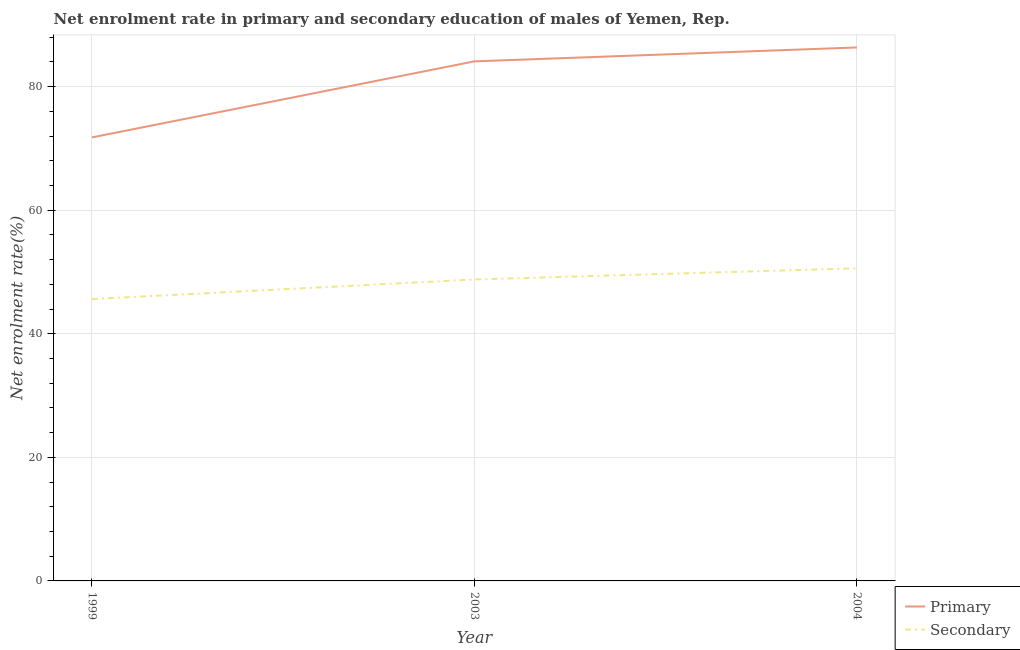How many different coloured lines are there?
Offer a terse response. 2. Does the line corresponding to enrollment rate in secondary education intersect with the line corresponding to enrollment rate in primary education?
Give a very brief answer. No. Is the number of lines equal to the number of legend labels?
Keep it short and to the point. Yes. What is the enrollment rate in secondary education in 2004?
Ensure brevity in your answer.  50.61. Across all years, what is the maximum enrollment rate in secondary education?
Offer a very short reply. 50.61. Across all years, what is the minimum enrollment rate in secondary education?
Provide a short and direct response. 45.62. In which year was the enrollment rate in secondary education minimum?
Keep it short and to the point. 1999. What is the total enrollment rate in primary education in the graph?
Your response must be concise. 242.25. What is the difference between the enrollment rate in primary education in 2003 and that in 2004?
Offer a terse response. -2.25. What is the difference between the enrollment rate in primary education in 2004 and the enrollment rate in secondary education in 1999?
Give a very brief answer. 40.73. What is the average enrollment rate in secondary education per year?
Your answer should be compact. 48.34. In the year 1999, what is the difference between the enrollment rate in secondary education and enrollment rate in primary education?
Your answer should be very brief. -26.17. In how many years, is the enrollment rate in primary education greater than 40 %?
Make the answer very short. 3. What is the ratio of the enrollment rate in secondary education in 1999 to that in 2004?
Your answer should be compact. 0.9. Is the enrollment rate in primary education in 1999 less than that in 2004?
Provide a succinct answer. Yes. Is the difference between the enrollment rate in secondary education in 1999 and 2004 greater than the difference between the enrollment rate in primary education in 1999 and 2004?
Your answer should be very brief. Yes. What is the difference between the highest and the second highest enrollment rate in primary education?
Make the answer very short. 2.25. What is the difference between the highest and the lowest enrollment rate in primary education?
Give a very brief answer. 14.56. In how many years, is the enrollment rate in secondary education greater than the average enrollment rate in secondary education taken over all years?
Ensure brevity in your answer.  2. Does the enrollment rate in secondary education monotonically increase over the years?
Provide a short and direct response. Yes. Is the enrollment rate in secondary education strictly less than the enrollment rate in primary education over the years?
Your response must be concise. Yes. What is the difference between two consecutive major ticks on the Y-axis?
Keep it short and to the point. 20. Are the values on the major ticks of Y-axis written in scientific E-notation?
Give a very brief answer. No. Does the graph contain any zero values?
Keep it short and to the point. No. Does the graph contain grids?
Keep it short and to the point. Yes. Where does the legend appear in the graph?
Offer a terse response. Bottom right. How are the legend labels stacked?
Provide a succinct answer. Vertical. What is the title of the graph?
Your answer should be very brief. Net enrolment rate in primary and secondary education of males of Yemen, Rep. What is the label or title of the Y-axis?
Your answer should be compact. Net enrolment rate(%). What is the Net enrolment rate(%) in Primary in 1999?
Give a very brief answer. 71.79. What is the Net enrolment rate(%) of Secondary in 1999?
Your response must be concise. 45.62. What is the Net enrolment rate(%) of Primary in 2003?
Your answer should be compact. 84.1. What is the Net enrolment rate(%) of Secondary in 2003?
Offer a very short reply. 48.8. What is the Net enrolment rate(%) of Primary in 2004?
Keep it short and to the point. 86.35. What is the Net enrolment rate(%) of Secondary in 2004?
Give a very brief answer. 50.61. Across all years, what is the maximum Net enrolment rate(%) of Primary?
Your answer should be compact. 86.35. Across all years, what is the maximum Net enrolment rate(%) of Secondary?
Make the answer very short. 50.61. Across all years, what is the minimum Net enrolment rate(%) of Primary?
Keep it short and to the point. 71.79. Across all years, what is the minimum Net enrolment rate(%) in Secondary?
Offer a terse response. 45.62. What is the total Net enrolment rate(%) of Primary in the graph?
Provide a short and direct response. 242.25. What is the total Net enrolment rate(%) of Secondary in the graph?
Provide a succinct answer. 145.03. What is the difference between the Net enrolment rate(%) in Primary in 1999 and that in 2003?
Ensure brevity in your answer.  -12.31. What is the difference between the Net enrolment rate(%) in Secondary in 1999 and that in 2003?
Offer a very short reply. -3.17. What is the difference between the Net enrolment rate(%) in Primary in 1999 and that in 2004?
Your answer should be very brief. -14.56. What is the difference between the Net enrolment rate(%) in Secondary in 1999 and that in 2004?
Your response must be concise. -4.98. What is the difference between the Net enrolment rate(%) in Primary in 2003 and that in 2004?
Your answer should be very brief. -2.25. What is the difference between the Net enrolment rate(%) of Secondary in 2003 and that in 2004?
Offer a terse response. -1.81. What is the difference between the Net enrolment rate(%) in Primary in 1999 and the Net enrolment rate(%) in Secondary in 2003?
Offer a very short reply. 23. What is the difference between the Net enrolment rate(%) in Primary in 1999 and the Net enrolment rate(%) in Secondary in 2004?
Your answer should be very brief. 21.19. What is the difference between the Net enrolment rate(%) of Primary in 2003 and the Net enrolment rate(%) of Secondary in 2004?
Your answer should be compact. 33.5. What is the average Net enrolment rate(%) in Primary per year?
Offer a very short reply. 80.75. What is the average Net enrolment rate(%) in Secondary per year?
Provide a short and direct response. 48.34. In the year 1999, what is the difference between the Net enrolment rate(%) in Primary and Net enrolment rate(%) in Secondary?
Your answer should be compact. 26.17. In the year 2003, what is the difference between the Net enrolment rate(%) of Primary and Net enrolment rate(%) of Secondary?
Give a very brief answer. 35.31. In the year 2004, what is the difference between the Net enrolment rate(%) of Primary and Net enrolment rate(%) of Secondary?
Your response must be concise. 35.75. What is the ratio of the Net enrolment rate(%) in Primary in 1999 to that in 2003?
Provide a succinct answer. 0.85. What is the ratio of the Net enrolment rate(%) of Secondary in 1999 to that in 2003?
Provide a short and direct response. 0.94. What is the ratio of the Net enrolment rate(%) of Primary in 1999 to that in 2004?
Your response must be concise. 0.83. What is the ratio of the Net enrolment rate(%) of Secondary in 1999 to that in 2004?
Ensure brevity in your answer.  0.9. What is the ratio of the Net enrolment rate(%) of Primary in 2003 to that in 2004?
Provide a succinct answer. 0.97. What is the ratio of the Net enrolment rate(%) in Secondary in 2003 to that in 2004?
Ensure brevity in your answer.  0.96. What is the difference between the highest and the second highest Net enrolment rate(%) of Primary?
Provide a short and direct response. 2.25. What is the difference between the highest and the second highest Net enrolment rate(%) of Secondary?
Provide a short and direct response. 1.81. What is the difference between the highest and the lowest Net enrolment rate(%) in Primary?
Ensure brevity in your answer.  14.56. What is the difference between the highest and the lowest Net enrolment rate(%) of Secondary?
Provide a succinct answer. 4.98. 